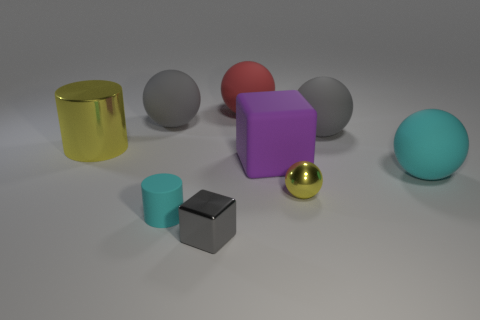Which of these objects looks the softest? While it's hard to determine softness from a visual inspection, by conventional associations, objects with a matte texture, such as the matte gray sphere or the matte pink sphere, might be perceived as softer compared to the metallic ones. 